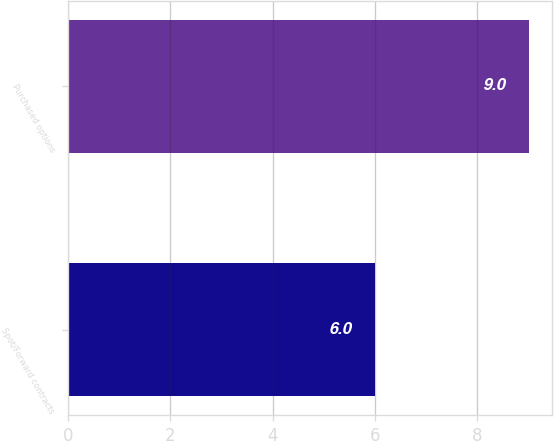<chart> <loc_0><loc_0><loc_500><loc_500><bar_chart><fcel>Spot/Forward contracts<fcel>Purchased options<nl><fcel>6<fcel>9<nl></chart> 